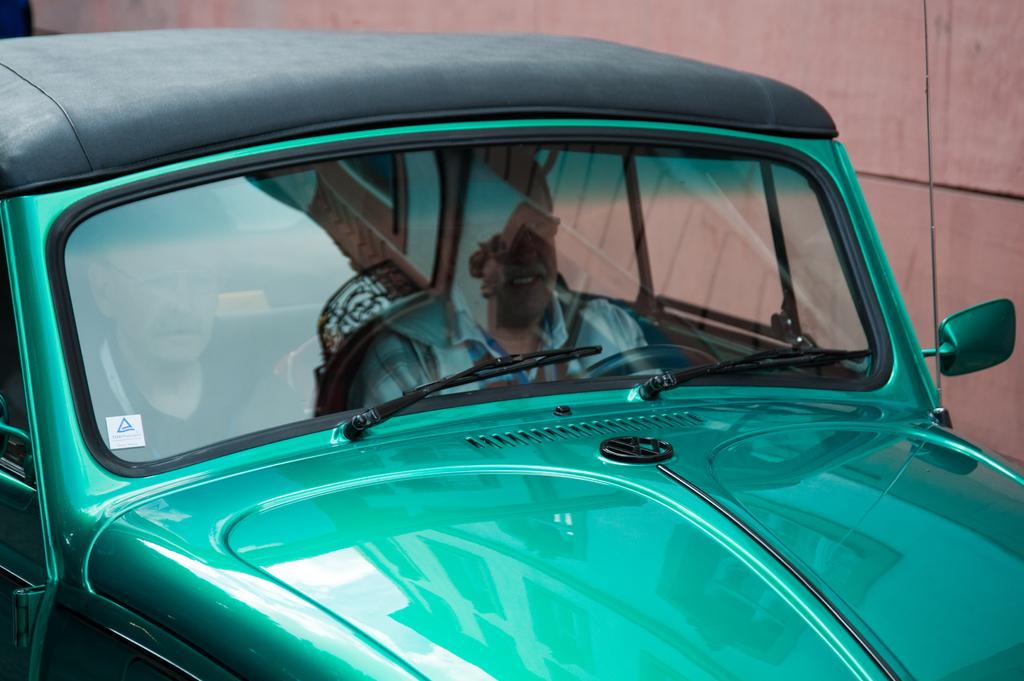How many people are sitting on the car in the image? There are two persons sitting on the car in the image. What can be seen in the background of the image? There is a wall in the background of the image. What type of nut is being used to fix the car in the image? There is no nut visible in the image, and the car does not appear to be in need of repair. 